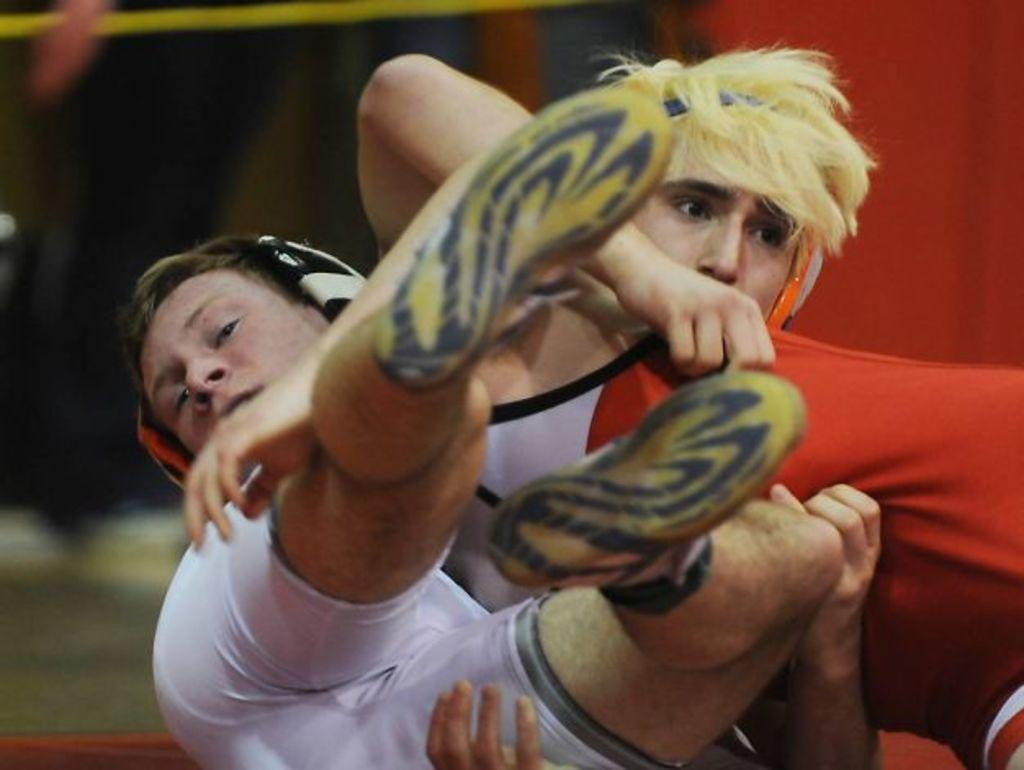How many people are in the image? There are two persons in the image. What are the two persons doing in the image? The two persons are sitting. What are the two persons holding in the image? The two persons are holding something. Is there a cave visible in the image? No, there is no cave present in the image. What type of motion can be observed in the image? There is no motion visible in the image; the two persons are sitting still. 